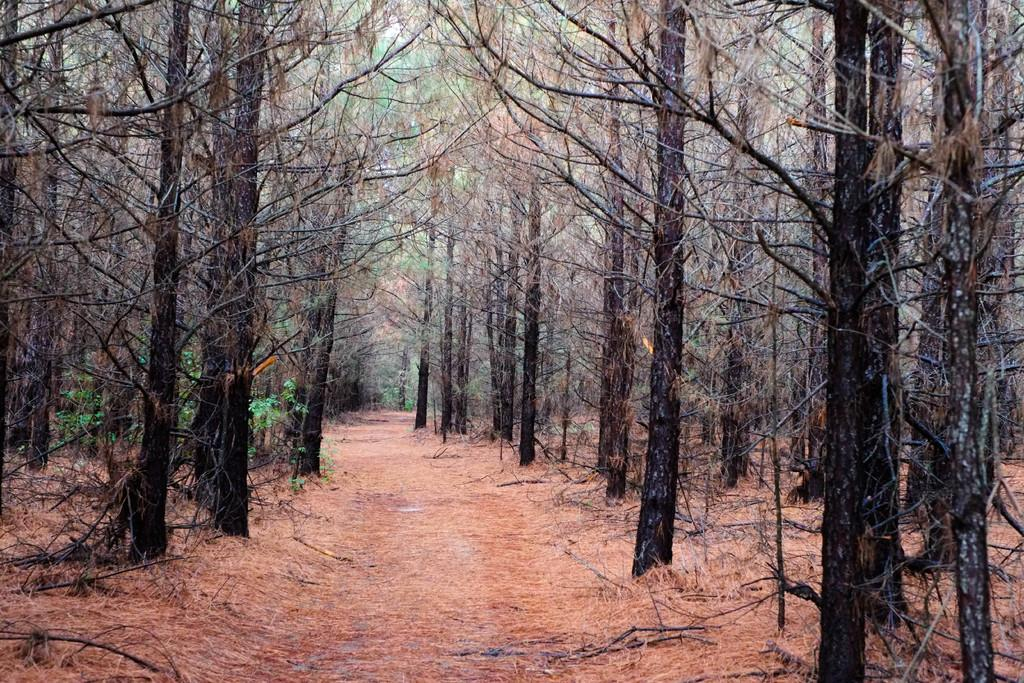What type of environment is shown in the image? The image appears to depict a forest. What can be seen at the bottom of the image? There is a path at the bottom of the image. What surrounds the path in the image? There are many trees on both sides of the path. What type of scarf is being used to represent the nation in the image? There is no scarf or representation of a nation present in the image; it depicts a forest with a path and trees. 